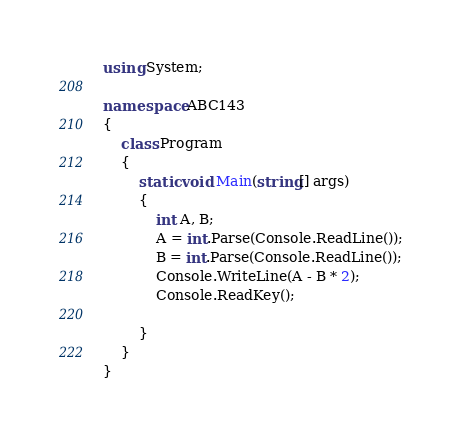<code> <loc_0><loc_0><loc_500><loc_500><_C#_>using System;

namespace ABC143
{
    class Program
    {
        static void Main(string[] args)
        {
            int A, B;
            A = int.Parse(Console.ReadLine());
            B = int.Parse(Console.ReadLine());
            Console.WriteLine(A - B * 2);
            Console.ReadKey();

        }
    }
}</code> 